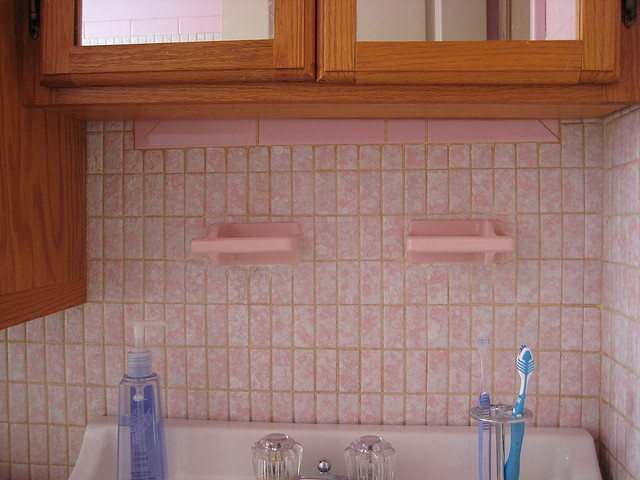Describe the objects in this image and their specific colors. I can see sink in maroon, darkgray, and gray tones, bottle in maroon, purple, and gray tones, toothbrush in maroon, darkgray, and gray tones, and toothbrush in maroon, teal, gray, and lightgray tones in this image. 